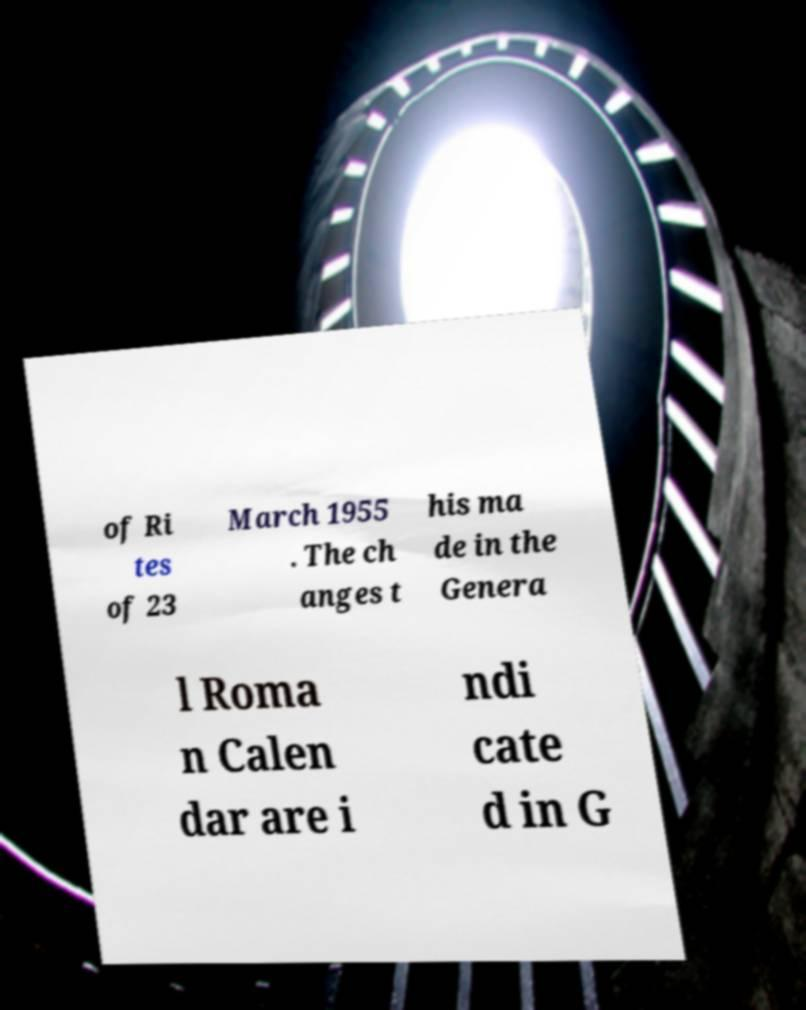There's text embedded in this image that I need extracted. Can you transcribe it verbatim? of Ri tes of 23 March 1955 . The ch anges t his ma de in the Genera l Roma n Calen dar are i ndi cate d in G 